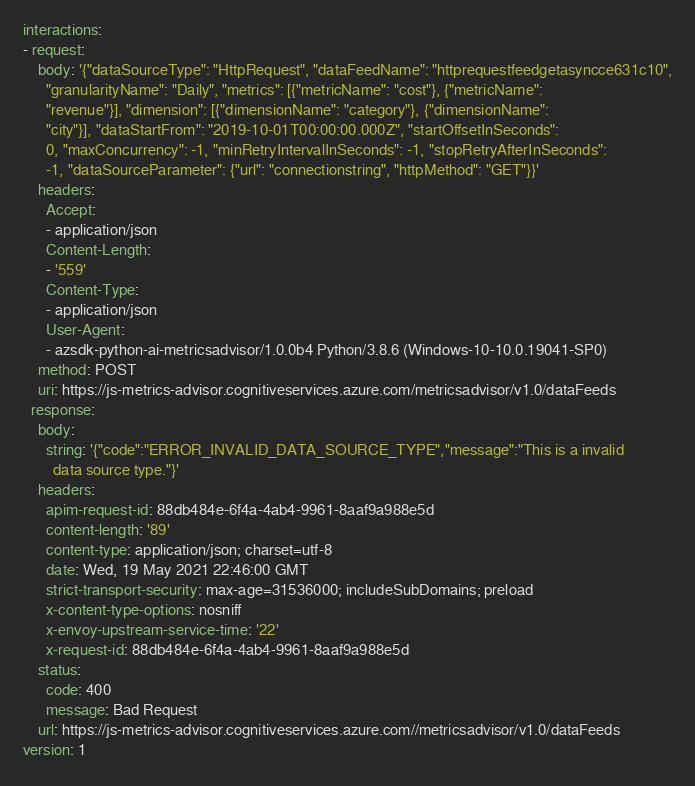<code> <loc_0><loc_0><loc_500><loc_500><_YAML_>interactions:
- request:
    body: '{"dataSourceType": "HttpRequest", "dataFeedName": "httprequestfeedgetasyncce631c10",
      "granularityName": "Daily", "metrics": [{"metricName": "cost"}, {"metricName":
      "revenue"}], "dimension": [{"dimensionName": "category"}, {"dimensionName":
      "city"}], "dataStartFrom": "2019-10-01T00:00:00.000Z", "startOffsetInSeconds":
      0, "maxConcurrency": -1, "minRetryIntervalInSeconds": -1, "stopRetryAfterInSeconds":
      -1, "dataSourceParameter": {"url": "connectionstring", "httpMethod": "GET"}}'
    headers:
      Accept:
      - application/json
      Content-Length:
      - '559'
      Content-Type:
      - application/json
      User-Agent:
      - azsdk-python-ai-metricsadvisor/1.0.0b4 Python/3.8.6 (Windows-10-10.0.19041-SP0)
    method: POST
    uri: https://js-metrics-advisor.cognitiveservices.azure.com/metricsadvisor/v1.0/dataFeeds
  response:
    body:
      string: '{"code":"ERROR_INVALID_DATA_SOURCE_TYPE","message":"This is a invalid
        data source type."}'
    headers:
      apim-request-id: 88db484e-6f4a-4ab4-9961-8aaf9a988e5d
      content-length: '89'
      content-type: application/json; charset=utf-8
      date: Wed, 19 May 2021 22:46:00 GMT
      strict-transport-security: max-age=31536000; includeSubDomains; preload
      x-content-type-options: nosniff
      x-envoy-upstream-service-time: '22'
      x-request-id: 88db484e-6f4a-4ab4-9961-8aaf9a988e5d
    status:
      code: 400
      message: Bad Request
    url: https://js-metrics-advisor.cognitiveservices.azure.com//metricsadvisor/v1.0/dataFeeds
version: 1
</code> 